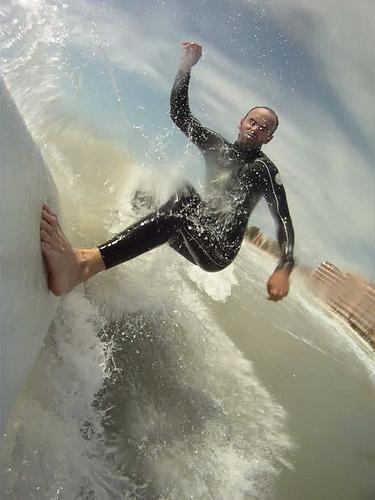What foot is in the picture?
Be succinct. Left. Is he wet?
Concise answer only. Yes. What is he wearing?
Give a very brief answer. Wetsuit. Is it sunny on this beach?
Short answer required. Yes. 